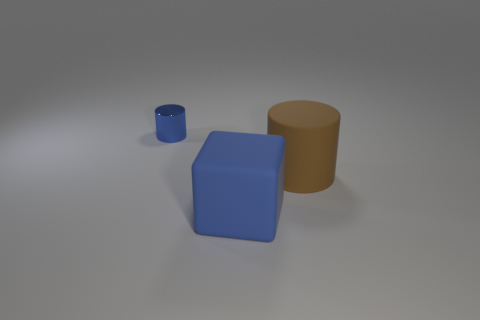How many objects are there, and can you describe their colors and shapes? There are three objects in the image. The first is a small blue cylinder, the second is a larger blue cube, and the third is a large brown cylinder. They are all placed on a grey surface, likely depicting a simple 3D modeling scene. 